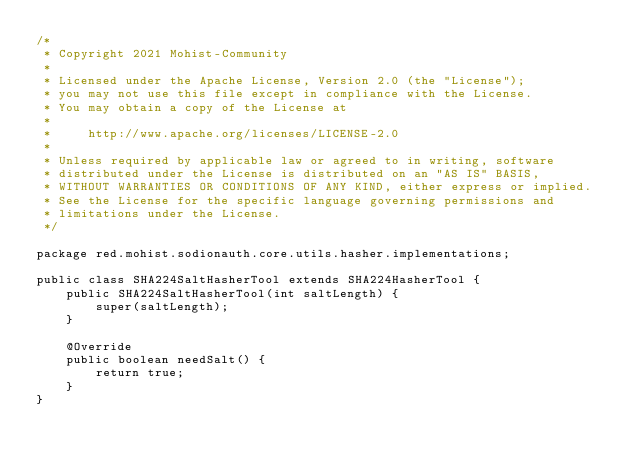Convert code to text. <code><loc_0><loc_0><loc_500><loc_500><_Java_>/*
 * Copyright 2021 Mohist-Community
 *
 * Licensed under the Apache License, Version 2.0 (the "License");
 * you may not use this file except in compliance with the License.
 * You may obtain a copy of the License at
 *
 *     http://www.apache.org/licenses/LICENSE-2.0
 *
 * Unless required by applicable law or agreed to in writing, software
 * distributed under the License is distributed on an "AS IS" BASIS,
 * WITHOUT WARRANTIES OR CONDITIONS OF ANY KIND, either express or implied.
 * See the License for the specific language governing permissions and
 * limitations under the License.
 */

package red.mohist.sodionauth.core.utils.hasher.implementations;

public class SHA224SaltHasherTool extends SHA224HasherTool {
    public SHA224SaltHasherTool(int saltLength) {
        super(saltLength);
    }

    @Override
    public boolean needSalt() {
        return true;
    }
}
</code> 